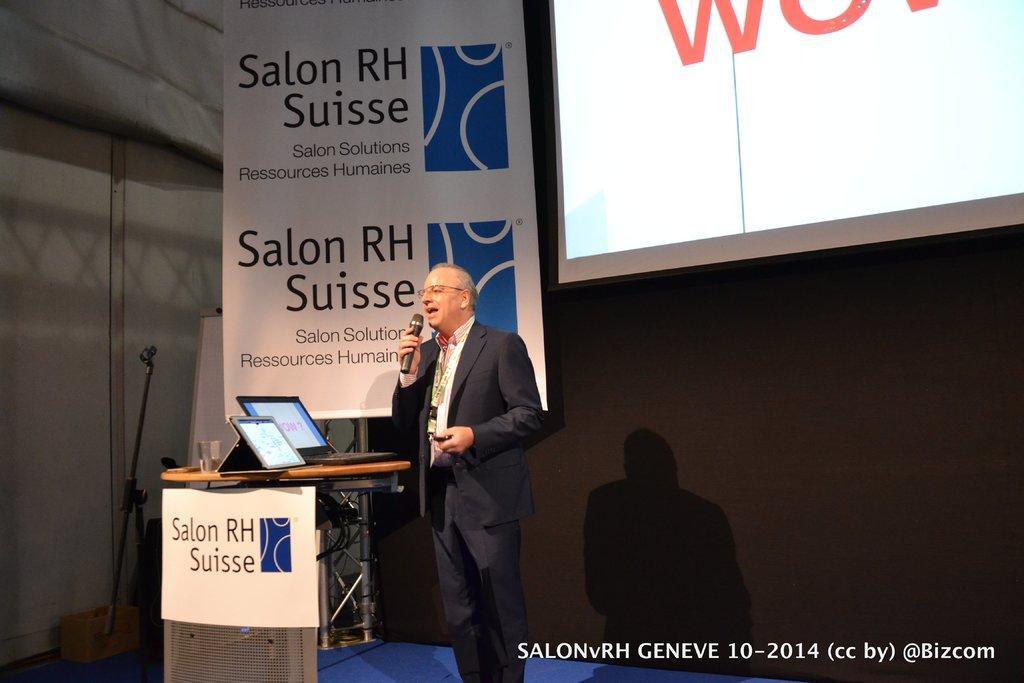Can you describe this image briefly? In this image we can see a projector screen in the image. There are few objects placed on the ground. A man is speaking into a microphone and holding an object in hand. There are many objects placed on the table. There is an advertising board in the image. 